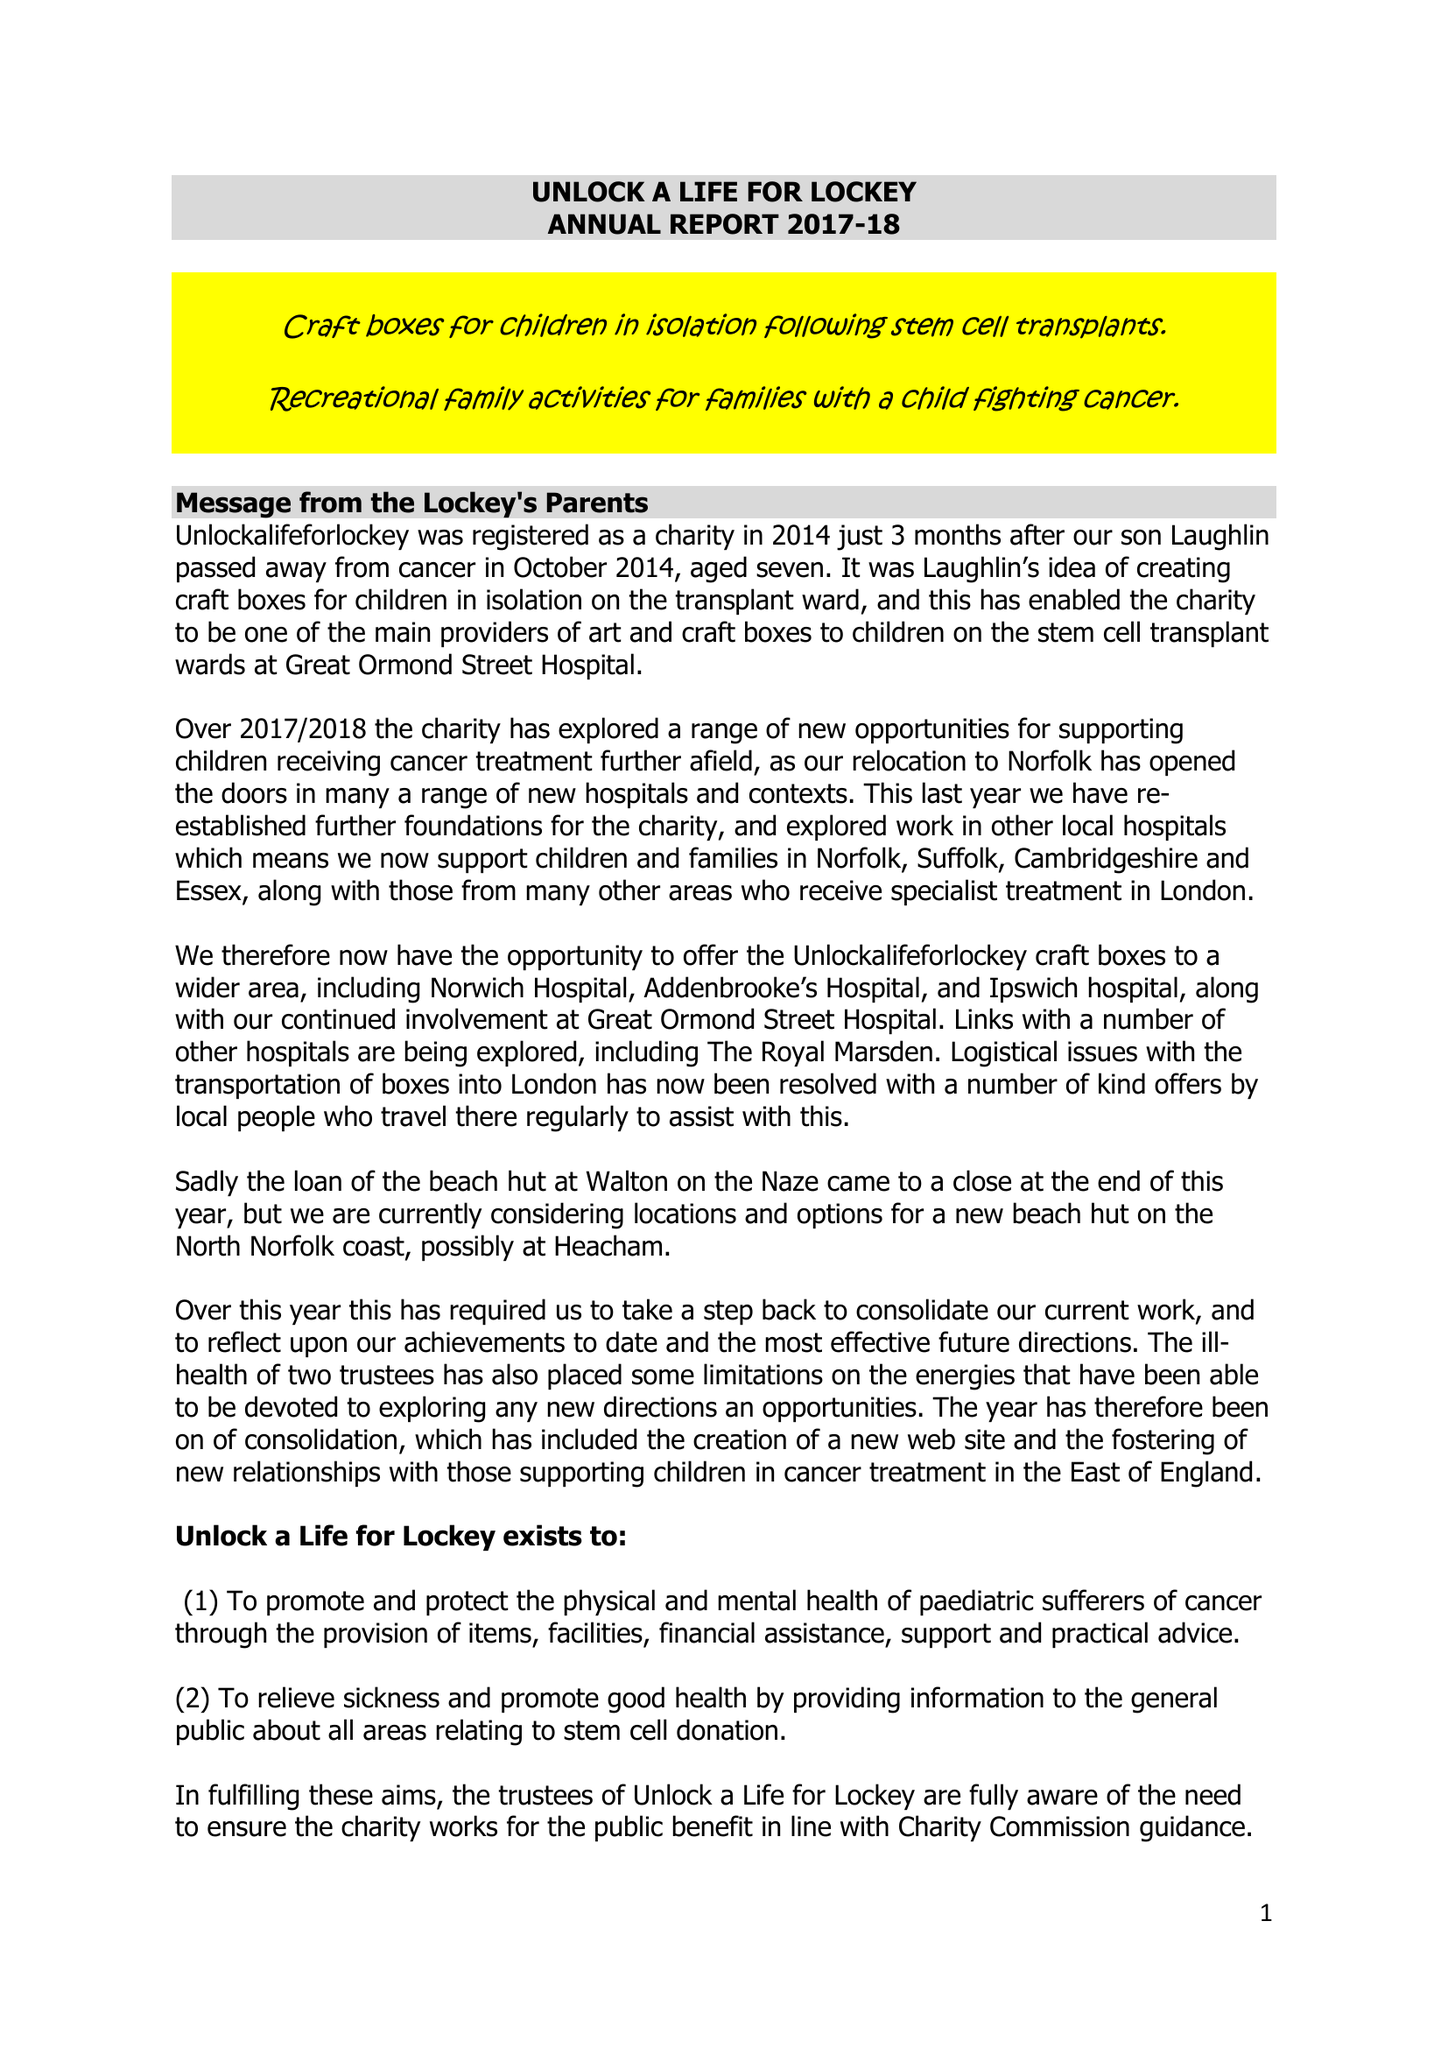What is the value for the charity_name?
Answer the question using a single word or phrase. Unlock A Life For Lockey 